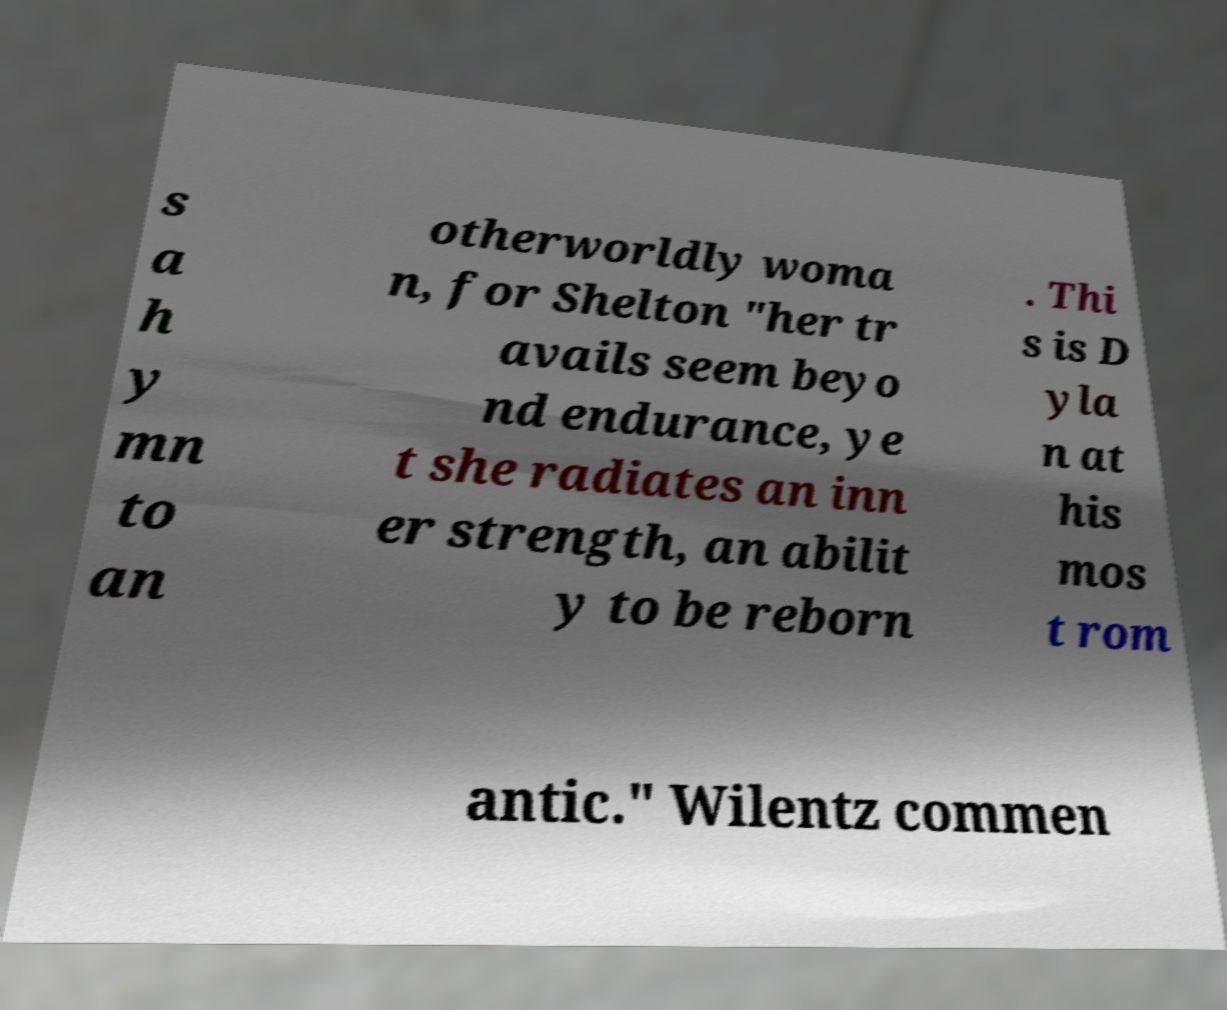Please identify and transcribe the text found in this image. s a h y mn to an otherworldly woma n, for Shelton "her tr avails seem beyo nd endurance, ye t she radiates an inn er strength, an abilit y to be reborn . Thi s is D yla n at his mos t rom antic." Wilentz commen 